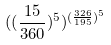Convert formula to latex. <formula><loc_0><loc_0><loc_500><loc_500>( ( \frac { 1 5 } { 3 6 0 } ) ^ { 5 } ) ^ { ( \frac { 3 2 6 } { 1 9 5 } ) ^ { 5 } }</formula> 